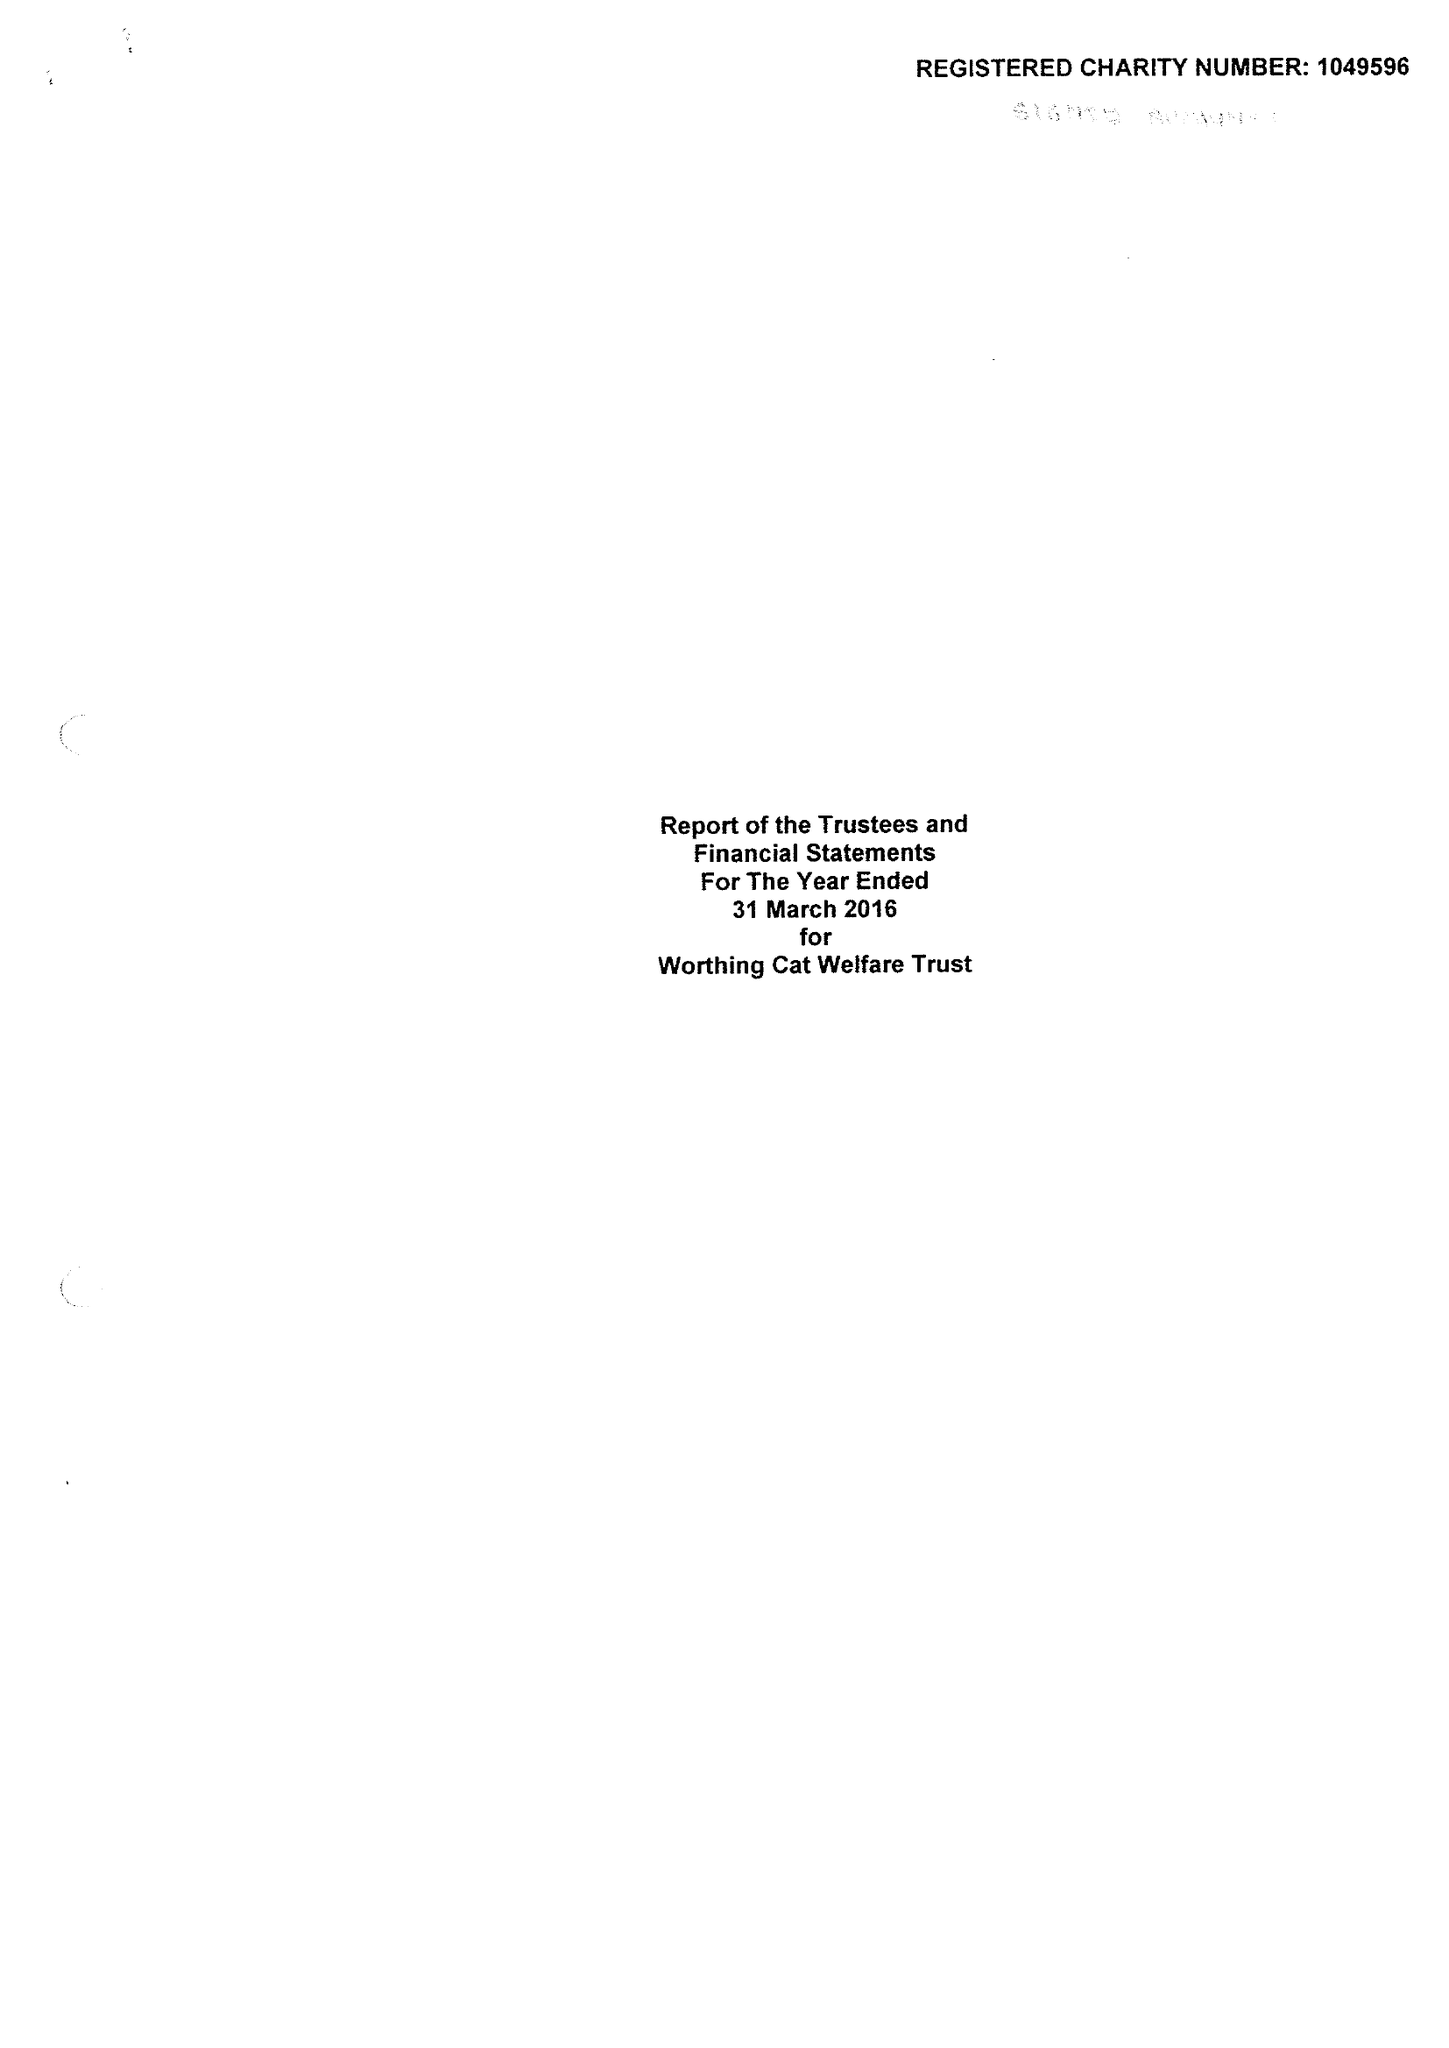What is the value for the spending_annually_in_british_pounds?
Answer the question using a single word or phrase. 136367.00 